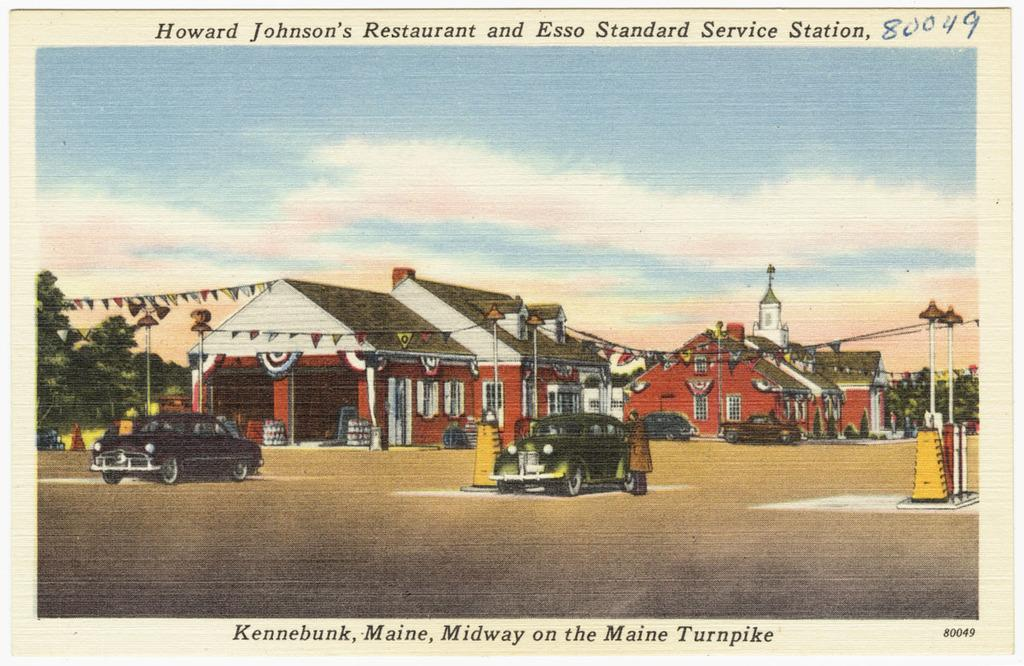What type of structures can be seen in the image? There are houses in the image. What else is visible besides the houses? There are vehicles and trees in the image. Can you describe the text in the image? There is text at the top and bottom of the image. How many giraffes can be seen in the image? There are no giraffes present in the image. What time of day is depicted in the image, based on the hour? The image does not provide information about the time of day or any specific hour. 